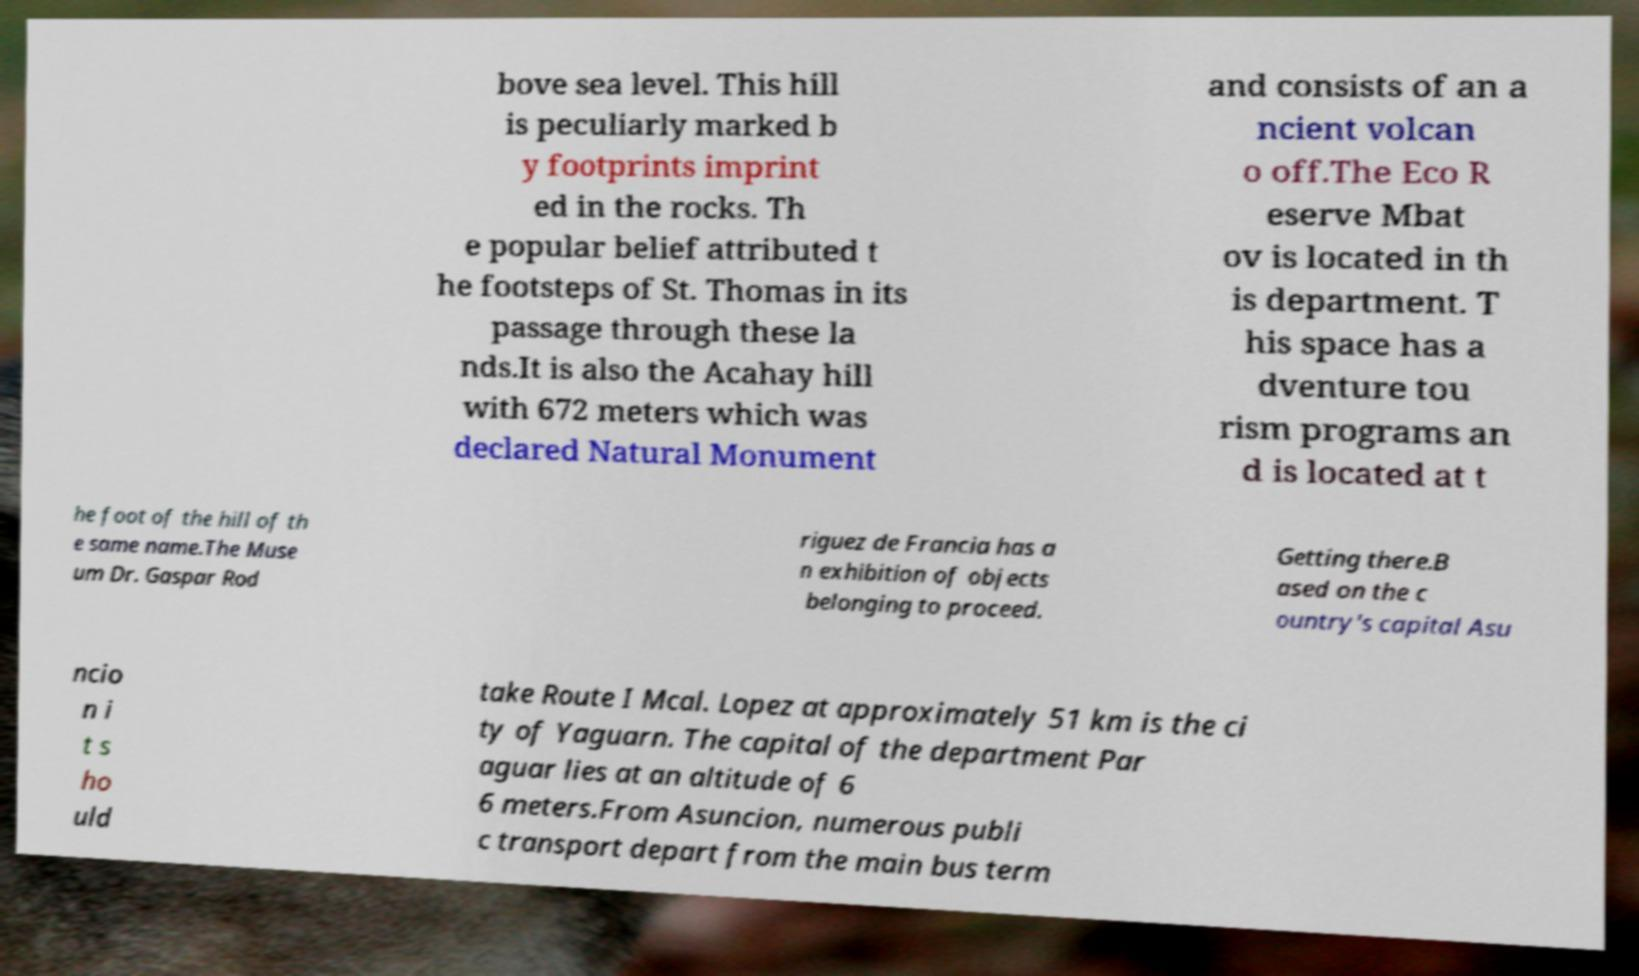Please read and relay the text visible in this image. What does it say? bove sea level. This hill is peculiarly marked b y footprints imprint ed in the rocks. Th e popular belief attributed t he footsteps of St. Thomas in its passage through these la nds.It is also the Acahay hill with 672 meters which was declared Natural Monument and consists of an a ncient volcan o off.The Eco R eserve Mbat ov is located in th is department. T his space has a dventure tou rism programs an d is located at t he foot of the hill of th e same name.The Muse um Dr. Gaspar Rod riguez de Francia has a n exhibition of objects belonging to proceed. Getting there.B ased on the c ountry's capital Asu ncio n i t s ho uld take Route I Mcal. Lopez at approximately 51 km is the ci ty of Yaguarn. The capital of the department Par aguar lies at an altitude of 6 6 meters.From Asuncion, numerous publi c transport depart from the main bus term 